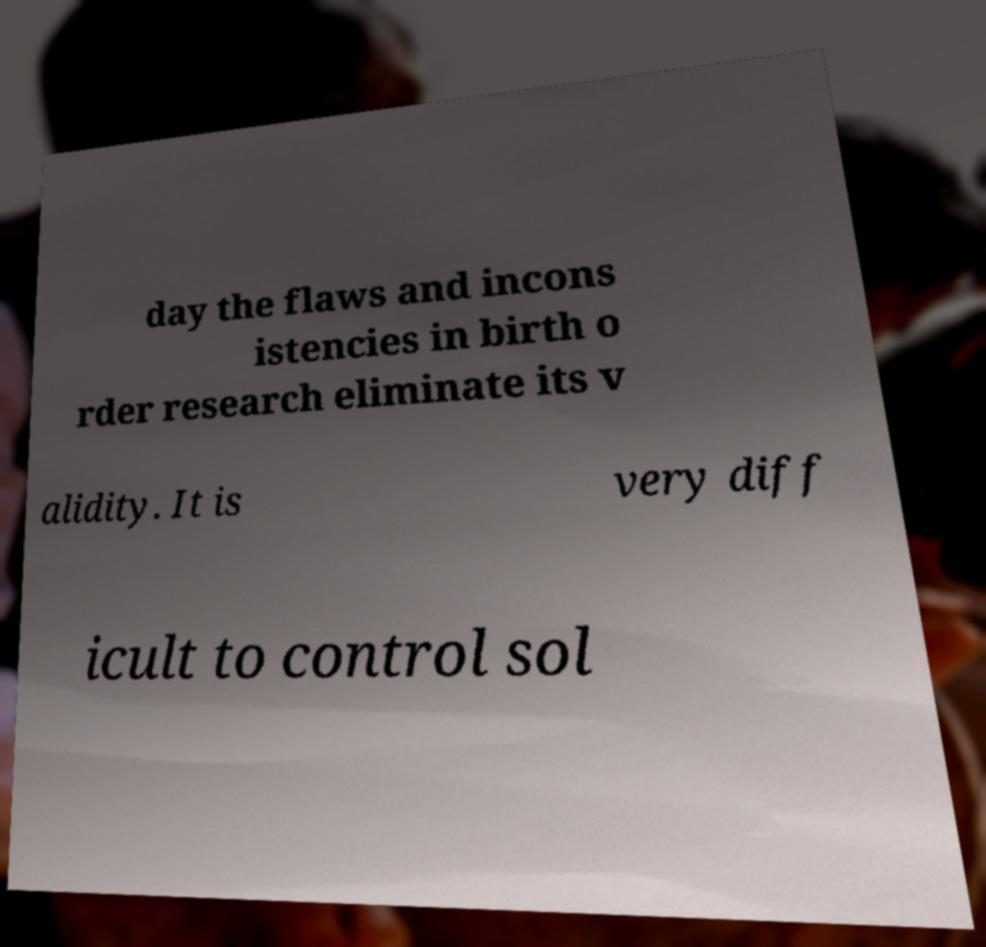Please identify and transcribe the text found in this image. day the flaws and incons istencies in birth o rder research eliminate its v alidity. It is very diff icult to control sol 